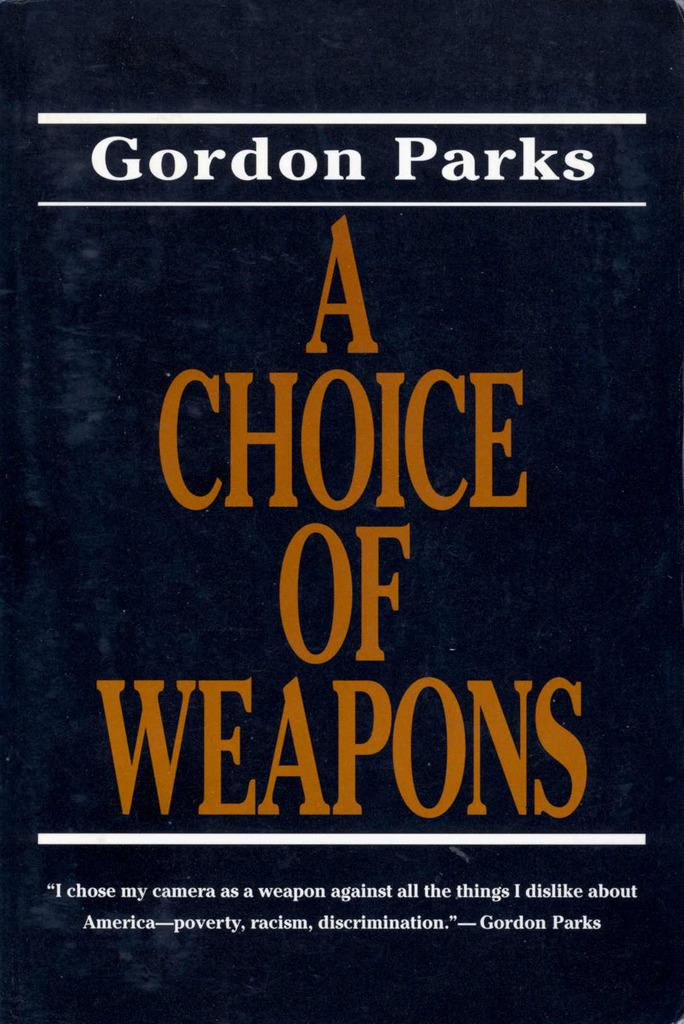<image>
Provide a brief description of the given image. Gordon Parks has written a book called A Choice of Weapons. 